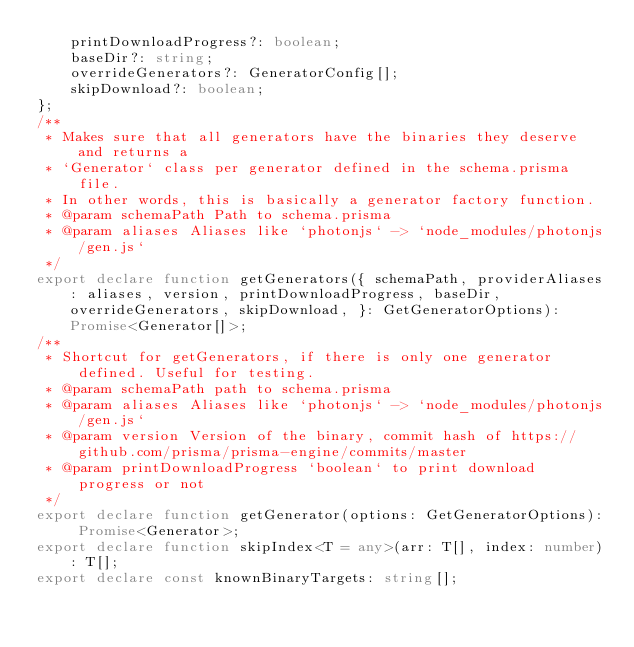Convert code to text. <code><loc_0><loc_0><loc_500><loc_500><_TypeScript_>    printDownloadProgress?: boolean;
    baseDir?: string;
    overrideGenerators?: GeneratorConfig[];
    skipDownload?: boolean;
};
/**
 * Makes sure that all generators have the binaries they deserve and returns a
 * `Generator` class per generator defined in the schema.prisma file.
 * In other words, this is basically a generator factory function.
 * @param schemaPath Path to schema.prisma
 * @param aliases Aliases like `photonjs` -> `node_modules/photonjs/gen.js`
 */
export declare function getGenerators({ schemaPath, providerAliases: aliases, version, printDownloadProgress, baseDir, overrideGenerators, skipDownload, }: GetGeneratorOptions): Promise<Generator[]>;
/**
 * Shortcut for getGenerators, if there is only one generator defined. Useful for testing.
 * @param schemaPath path to schema.prisma
 * @param aliases Aliases like `photonjs` -> `node_modules/photonjs/gen.js`
 * @param version Version of the binary, commit hash of https://github.com/prisma/prisma-engine/commits/master
 * @param printDownloadProgress `boolean` to print download progress or not
 */
export declare function getGenerator(options: GetGeneratorOptions): Promise<Generator>;
export declare function skipIndex<T = any>(arr: T[], index: number): T[];
export declare const knownBinaryTargets: string[];
</code> 